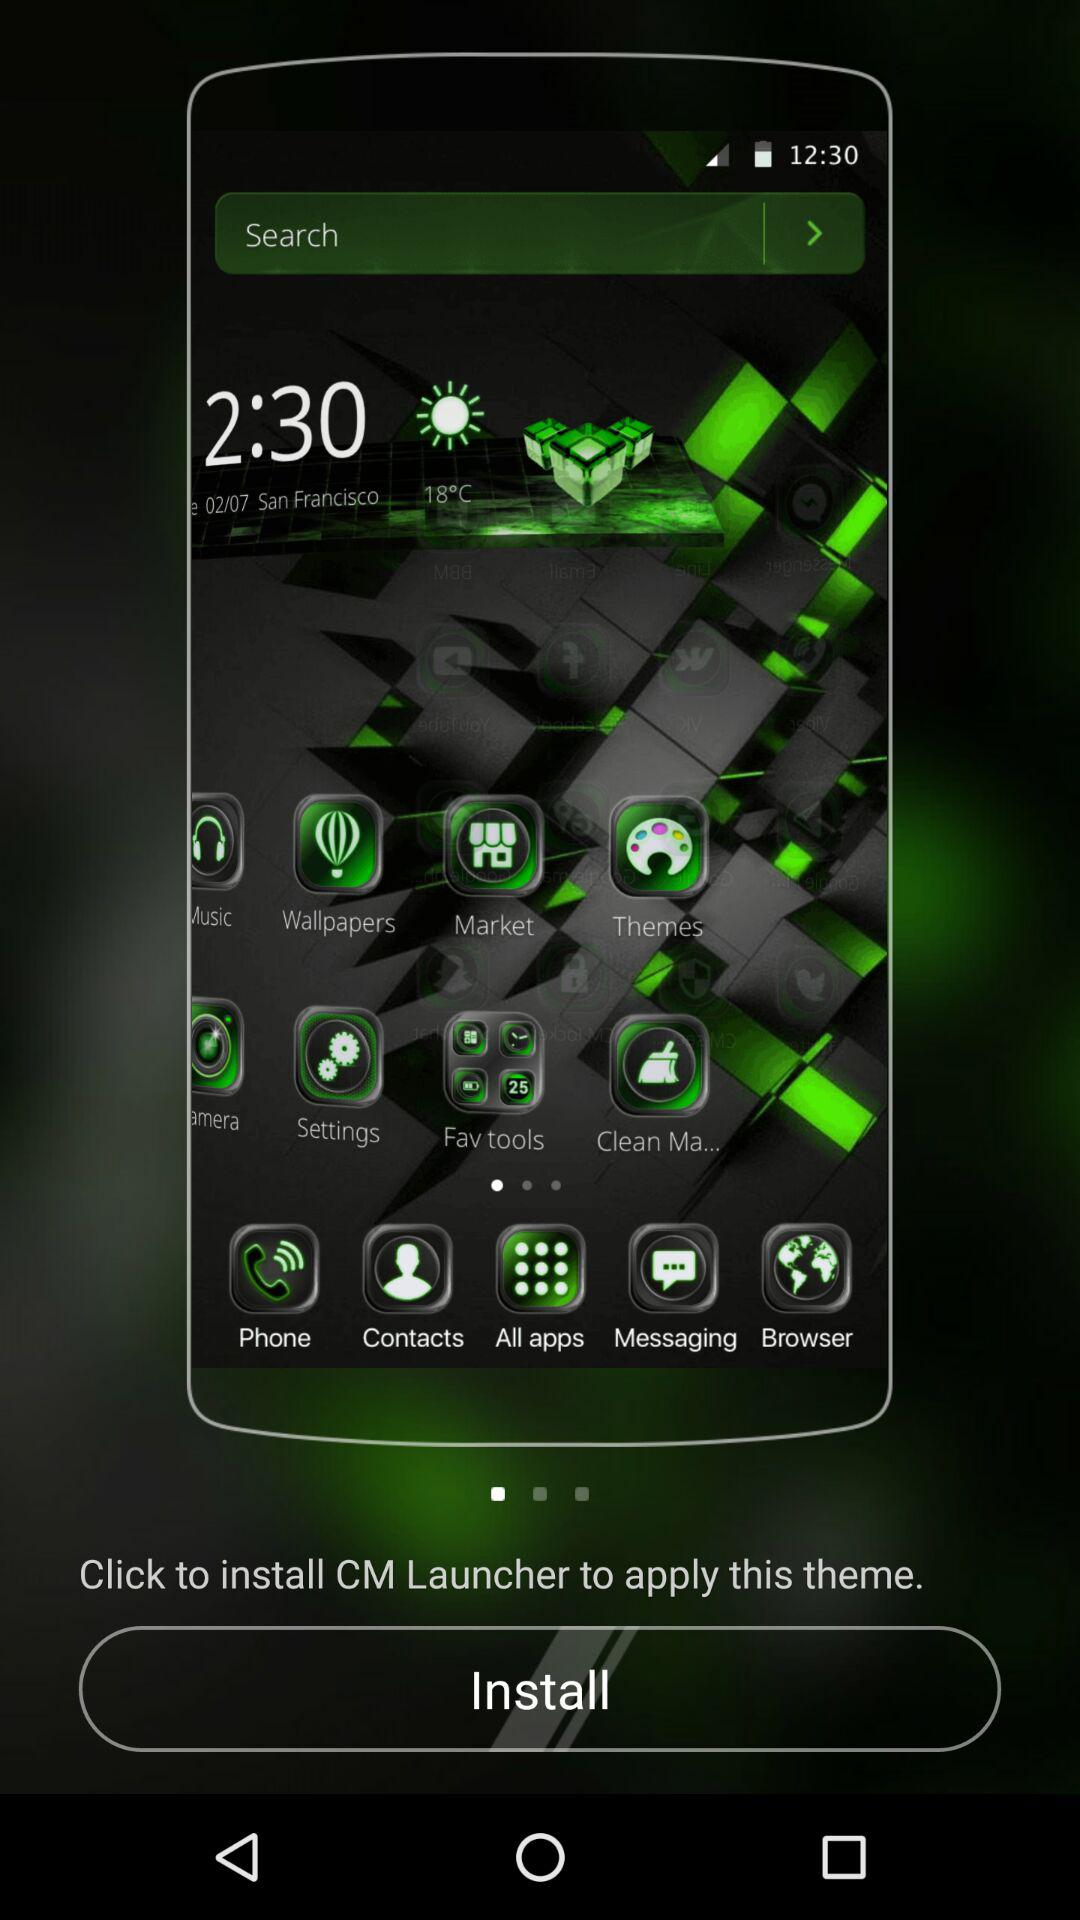What is the name of the application that is required to be installed? The name of the application is "CM Launcher". 